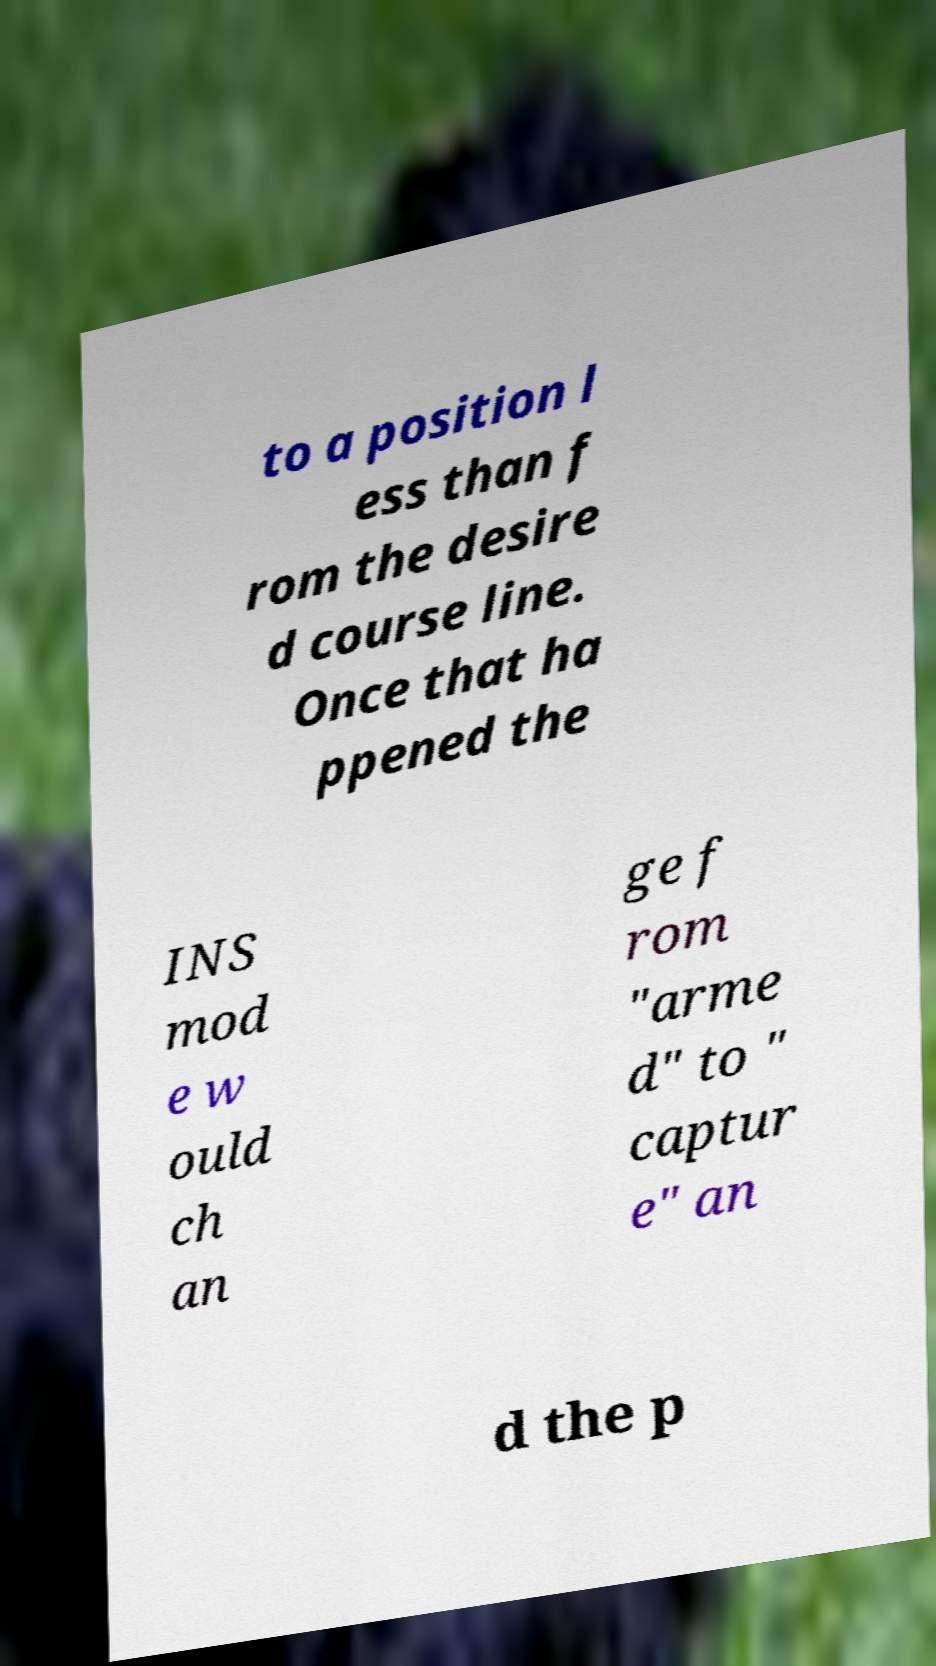Can you accurately transcribe the text from the provided image for me? to a position l ess than f rom the desire d course line. Once that ha ppened the INS mod e w ould ch an ge f rom "arme d" to " captur e" an d the p 